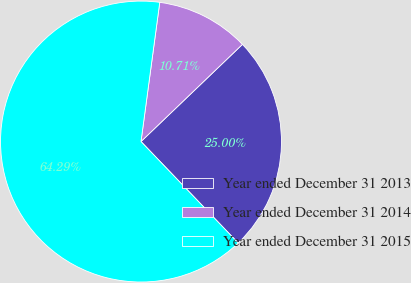<chart> <loc_0><loc_0><loc_500><loc_500><pie_chart><fcel>Year ended December 31 2013<fcel>Year ended December 31 2014<fcel>Year ended December 31 2015<nl><fcel>25.0%<fcel>10.71%<fcel>64.29%<nl></chart> 